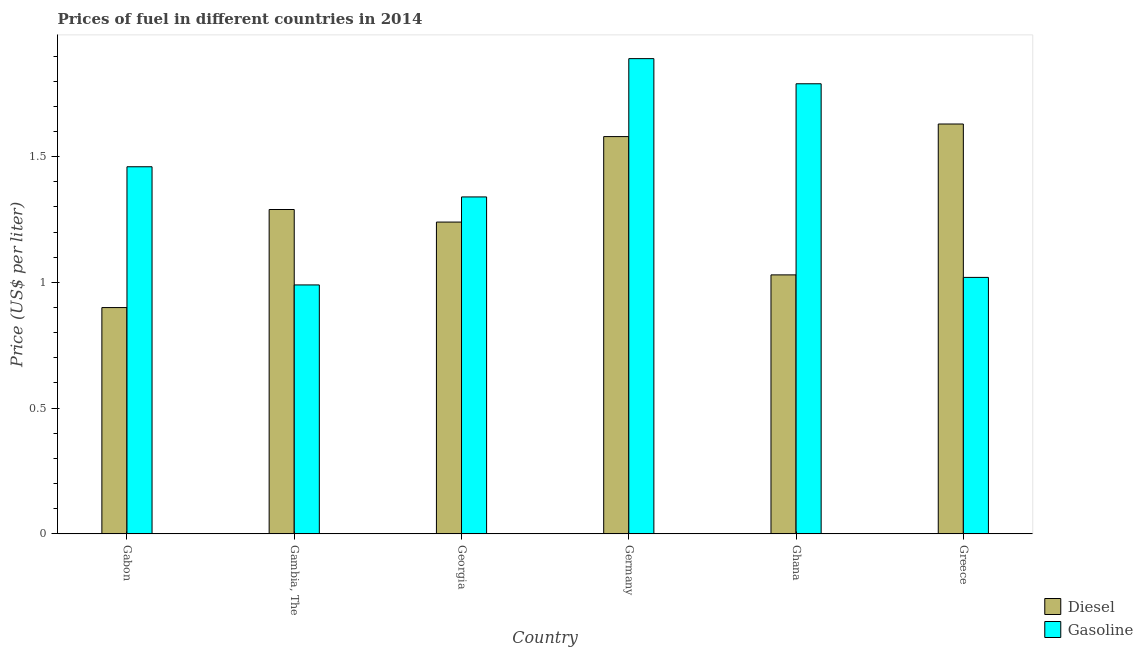Are the number of bars on each tick of the X-axis equal?
Keep it short and to the point. Yes. What is the label of the 3rd group of bars from the left?
Give a very brief answer. Georgia. In how many cases, is the number of bars for a given country not equal to the number of legend labels?
Ensure brevity in your answer.  0. What is the gasoline price in Gambia, The?
Provide a short and direct response. 0.99. Across all countries, what is the maximum gasoline price?
Keep it short and to the point. 1.89. In which country was the gasoline price minimum?
Keep it short and to the point. Gambia, The. What is the total diesel price in the graph?
Provide a succinct answer. 7.67. What is the difference between the diesel price in Gambia, The and that in Georgia?
Provide a short and direct response. 0.05. What is the difference between the diesel price in Ghana and the gasoline price in Gambia, The?
Give a very brief answer. 0.04. What is the average gasoline price per country?
Give a very brief answer. 1.42. What is the difference between the gasoline price and diesel price in Greece?
Keep it short and to the point. -0.61. What is the ratio of the gasoline price in Georgia to that in Ghana?
Keep it short and to the point. 0.75. What is the difference between the highest and the second highest diesel price?
Provide a short and direct response. 0.05. What is the difference between the highest and the lowest gasoline price?
Your answer should be compact. 0.9. What does the 2nd bar from the left in Gabon represents?
Your answer should be very brief. Gasoline. What does the 1st bar from the right in Ghana represents?
Your response must be concise. Gasoline. How many bars are there?
Give a very brief answer. 12. Are all the bars in the graph horizontal?
Your response must be concise. No. How many countries are there in the graph?
Your answer should be compact. 6. What is the difference between two consecutive major ticks on the Y-axis?
Keep it short and to the point. 0.5. Are the values on the major ticks of Y-axis written in scientific E-notation?
Your answer should be very brief. No. Does the graph contain any zero values?
Ensure brevity in your answer.  No. What is the title of the graph?
Your response must be concise. Prices of fuel in different countries in 2014. What is the label or title of the Y-axis?
Provide a short and direct response. Price (US$ per liter). What is the Price (US$ per liter) of Diesel in Gabon?
Keep it short and to the point. 0.9. What is the Price (US$ per liter) in Gasoline in Gabon?
Provide a short and direct response. 1.46. What is the Price (US$ per liter) in Diesel in Gambia, The?
Provide a succinct answer. 1.29. What is the Price (US$ per liter) in Gasoline in Gambia, The?
Provide a succinct answer. 0.99. What is the Price (US$ per liter) in Diesel in Georgia?
Give a very brief answer. 1.24. What is the Price (US$ per liter) in Gasoline in Georgia?
Provide a succinct answer. 1.34. What is the Price (US$ per liter) in Diesel in Germany?
Ensure brevity in your answer.  1.58. What is the Price (US$ per liter) of Gasoline in Germany?
Offer a terse response. 1.89. What is the Price (US$ per liter) in Gasoline in Ghana?
Your response must be concise. 1.79. What is the Price (US$ per liter) of Diesel in Greece?
Provide a short and direct response. 1.63. Across all countries, what is the maximum Price (US$ per liter) of Diesel?
Keep it short and to the point. 1.63. Across all countries, what is the maximum Price (US$ per liter) of Gasoline?
Your answer should be compact. 1.89. Across all countries, what is the minimum Price (US$ per liter) in Diesel?
Keep it short and to the point. 0.9. Across all countries, what is the minimum Price (US$ per liter) in Gasoline?
Provide a succinct answer. 0.99. What is the total Price (US$ per liter) in Diesel in the graph?
Offer a very short reply. 7.67. What is the total Price (US$ per liter) of Gasoline in the graph?
Your answer should be compact. 8.49. What is the difference between the Price (US$ per liter) of Diesel in Gabon and that in Gambia, The?
Make the answer very short. -0.39. What is the difference between the Price (US$ per liter) of Gasoline in Gabon and that in Gambia, The?
Keep it short and to the point. 0.47. What is the difference between the Price (US$ per liter) in Diesel in Gabon and that in Georgia?
Provide a succinct answer. -0.34. What is the difference between the Price (US$ per liter) of Gasoline in Gabon and that in Georgia?
Keep it short and to the point. 0.12. What is the difference between the Price (US$ per liter) in Diesel in Gabon and that in Germany?
Offer a terse response. -0.68. What is the difference between the Price (US$ per liter) of Gasoline in Gabon and that in Germany?
Offer a terse response. -0.43. What is the difference between the Price (US$ per liter) of Diesel in Gabon and that in Ghana?
Ensure brevity in your answer.  -0.13. What is the difference between the Price (US$ per liter) of Gasoline in Gabon and that in Ghana?
Make the answer very short. -0.33. What is the difference between the Price (US$ per liter) of Diesel in Gabon and that in Greece?
Provide a short and direct response. -0.73. What is the difference between the Price (US$ per liter) of Gasoline in Gabon and that in Greece?
Ensure brevity in your answer.  0.44. What is the difference between the Price (US$ per liter) in Gasoline in Gambia, The and that in Georgia?
Ensure brevity in your answer.  -0.35. What is the difference between the Price (US$ per liter) in Diesel in Gambia, The and that in Germany?
Provide a succinct answer. -0.29. What is the difference between the Price (US$ per liter) of Gasoline in Gambia, The and that in Germany?
Make the answer very short. -0.9. What is the difference between the Price (US$ per liter) of Diesel in Gambia, The and that in Ghana?
Give a very brief answer. 0.26. What is the difference between the Price (US$ per liter) in Gasoline in Gambia, The and that in Ghana?
Give a very brief answer. -0.8. What is the difference between the Price (US$ per liter) in Diesel in Gambia, The and that in Greece?
Ensure brevity in your answer.  -0.34. What is the difference between the Price (US$ per liter) in Gasoline in Gambia, The and that in Greece?
Ensure brevity in your answer.  -0.03. What is the difference between the Price (US$ per liter) in Diesel in Georgia and that in Germany?
Keep it short and to the point. -0.34. What is the difference between the Price (US$ per liter) of Gasoline in Georgia and that in Germany?
Offer a very short reply. -0.55. What is the difference between the Price (US$ per liter) of Diesel in Georgia and that in Ghana?
Offer a very short reply. 0.21. What is the difference between the Price (US$ per liter) of Gasoline in Georgia and that in Ghana?
Make the answer very short. -0.45. What is the difference between the Price (US$ per liter) of Diesel in Georgia and that in Greece?
Offer a terse response. -0.39. What is the difference between the Price (US$ per liter) of Gasoline in Georgia and that in Greece?
Offer a terse response. 0.32. What is the difference between the Price (US$ per liter) of Diesel in Germany and that in Ghana?
Offer a terse response. 0.55. What is the difference between the Price (US$ per liter) in Gasoline in Germany and that in Ghana?
Offer a very short reply. 0.1. What is the difference between the Price (US$ per liter) of Diesel in Germany and that in Greece?
Ensure brevity in your answer.  -0.05. What is the difference between the Price (US$ per liter) in Gasoline in Germany and that in Greece?
Give a very brief answer. 0.87. What is the difference between the Price (US$ per liter) of Diesel in Ghana and that in Greece?
Your response must be concise. -0.6. What is the difference between the Price (US$ per liter) in Gasoline in Ghana and that in Greece?
Offer a very short reply. 0.77. What is the difference between the Price (US$ per liter) of Diesel in Gabon and the Price (US$ per liter) of Gasoline in Gambia, The?
Make the answer very short. -0.09. What is the difference between the Price (US$ per liter) of Diesel in Gabon and the Price (US$ per liter) of Gasoline in Georgia?
Give a very brief answer. -0.44. What is the difference between the Price (US$ per liter) in Diesel in Gabon and the Price (US$ per liter) in Gasoline in Germany?
Offer a very short reply. -0.99. What is the difference between the Price (US$ per liter) in Diesel in Gabon and the Price (US$ per liter) in Gasoline in Ghana?
Offer a terse response. -0.89. What is the difference between the Price (US$ per liter) of Diesel in Gabon and the Price (US$ per liter) of Gasoline in Greece?
Ensure brevity in your answer.  -0.12. What is the difference between the Price (US$ per liter) of Diesel in Gambia, The and the Price (US$ per liter) of Gasoline in Georgia?
Offer a terse response. -0.05. What is the difference between the Price (US$ per liter) of Diesel in Gambia, The and the Price (US$ per liter) of Gasoline in Ghana?
Make the answer very short. -0.5. What is the difference between the Price (US$ per liter) in Diesel in Gambia, The and the Price (US$ per liter) in Gasoline in Greece?
Ensure brevity in your answer.  0.27. What is the difference between the Price (US$ per liter) of Diesel in Georgia and the Price (US$ per liter) of Gasoline in Germany?
Offer a very short reply. -0.65. What is the difference between the Price (US$ per liter) of Diesel in Georgia and the Price (US$ per liter) of Gasoline in Ghana?
Make the answer very short. -0.55. What is the difference between the Price (US$ per liter) in Diesel in Georgia and the Price (US$ per liter) in Gasoline in Greece?
Provide a succinct answer. 0.22. What is the difference between the Price (US$ per liter) in Diesel in Germany and the Price (US$ per liter) in Gasoline in Ghana?
Your response must be concise. -0.21. What is the difference between the Price (US$ per liter) in Diesel in Germany and the Price (US$ per liter) in Gasoline in Greece?
Your response must be concise. 0.56. What is the difference between the Price (US$ per liter) in Diesel in Ghana and the Price (US$ per liter) in Gasoline in Greece?
Offer a very short reply. 0.01. What is the average Price (US$ per liter) of Diesel per country?
Provide a succinct answer. 1.28. What is the average Price (US$ per liter) in Gasoline per country?
Your answer should be very brief. 1.42. What is the difference between the Price (US$ per liter) of Diesel and Price (US$ per liter) of Gasoline in Gabon?
Your response must be concise. -0.56. What is the difference between the Price (US$ per liter) of Diesel and Price (US$ per liter) of Gasoline in Germany?
Provide a short and direct response. -0.31. What is the difference between the Price (US$ per liter) in Diesel and Price (US$ per liter) in Gasoline in Ghana?
Provide a succinct answer. -0.76. What is the difference between the Price (US$ per liter) in Diesel and Price (US$ per liter) in Gasoline in Greece?
Make the answer very short. 0.61. What is the ratio of the Price (US$ per liter) of Diesel in Gabon to that in Gambia, The?
Offer a very short reply. 0.7. What is the ratio of the Price (US$ per liter) of Gasoline in Gabon to that in Gambia, The?
Keep it short and to the point. 1.47. What is the ratio of the Price (US$ per liter) of Diesel in Gabon to that in Georgia?
Your answer should be compact. 0.73. What is the ratio of the Price (US$ per liter) in Gasoline in Gabon to that in Georgia?
Offer a very short reply. 1.09. What is the ratio of the Price (US$ per liter) in Diesel in Gabon to that in Germany?
Ensure brevity in your answer.  0.57. What is the ratio of the Price (US$ per liter) in Gasoline in Gabon to that in Germany?
Give a very brief answer. 0.77. What is the ratio of the Price (US$ per liter) of Diesel in Gabon to that in Ghana?
Provide a short and direct response. 0.87. What is the ratio of the Price (US$ per liter) in Gasoline in Gabon to that in Ghana?
Provide a succinct answer. 0.82. What is the ratio of the Price (US$ per liter) in Diesel in Gabon to that in Greece?
Ensure brevity in your answer.  0.55. What is the ratio of the Price (US$ per liter) of Gasoline in Gabon to that in Greece?
Provide a succinct answer. 1.43. What is the ratio of the Price (US$ per liter) of Diesel in Gambia, The to that in Georgia?
Make the answer very short. 1.04. What is the ratio of the Price (US$ per liter) in Gasoline in Gambia, The to that in Georgia?
Provide a short and direct response. 0.74. What is the ratio of the Price (US$ per liter) in Diesel in Gambia, The to that in Germany?
Your answer should be compact. 0.82. What is the ratio of the Price (US$ per liter) in Gasoline in Gambia, The to that in Germany?
Your answer should be compact. 0.52. What is the ratio of the Price (US$ per liter) in Diesel in Gambia, The to that in Ghana?
Provide a short and direct response. 1.25. What is the ratio of the Price (US$ per liter) in Gasoline in Gambia, The to that in Ghana?
Provide a succinct answer. 0.55. What is the ratio of the Price (US$ per liter) in Diesel in Gambia, The to that in Greece?
Offer a very short reply. 0.79. What is the ratio of the Price (US$ per liter) in Gasoline in Gambia, The to that in Greece?
Offer a terse response. 0.97. What is the ratio of the Price (US$ per liter) of Diesel in Georgia to that in Germany?
Ensure brevity in your answer.  0.78. What is the ratio of the Price (US$ per liter) in Gasoline in Georgia to that in Germany?
Offer a terse response. 0.71. What is the ratio of the Price (US$ per liter) in Diesel in Georgia to that in Ghana?
Ensure brevity in your answer.  1.2. What is the ratio of the Price (US$ per liter) of Gasoline in Georgia to that in Ghana?
Your response must be concise. 0.75. What is the ratio of the Price (US$ per liter) of Diesel in Georgia to that in Greece?
Your response must be concise. 0.76. What is the ratio of the Price (US$ per liter) of Gasoline in Georgia to that in Greece?
Offer a terse response. 1.31. What is the ratio of the Price (US$ per liter) in Diesel in Germany to that in Ghana?
Your response must be concise. 1.53. What is the ratio of the Price (US$ per liter) of Gasoline in Germany to that in Ghana?
Your answer should be very brief. 1.06. What is the ratio of the Price (US$ per liter) in Diesel in Germany to that in Greece?
Keep it short and to the point. 0.97. What is the ratio of the Price (US$ per liter) of Gasoline in Germany to that in Greece?
Give a very brief answer. 1.85. What is the ratio of the Price (US$ per liter) in Diesel in Ghana to that in Greece?
Make the answer very short. 0.63. What is the ratio of the Price (US$ per liter) of Gasoline in Ghana to that in Greece?
Provide a short and direct response. 1.75. What is the difference between the highest and the second highest Price (US$ per liter) of Diesel?
Provide a succinct answer. 0.05. What is the difference between the highest and the second highest Price (US$ per liter) in Gasoline?
Ensure brevity in your answer.  0.1. What is the difference between the highest and the lowest Price (US$ per liter) of Diesel?
Keep it short and to the point. 0.73. 